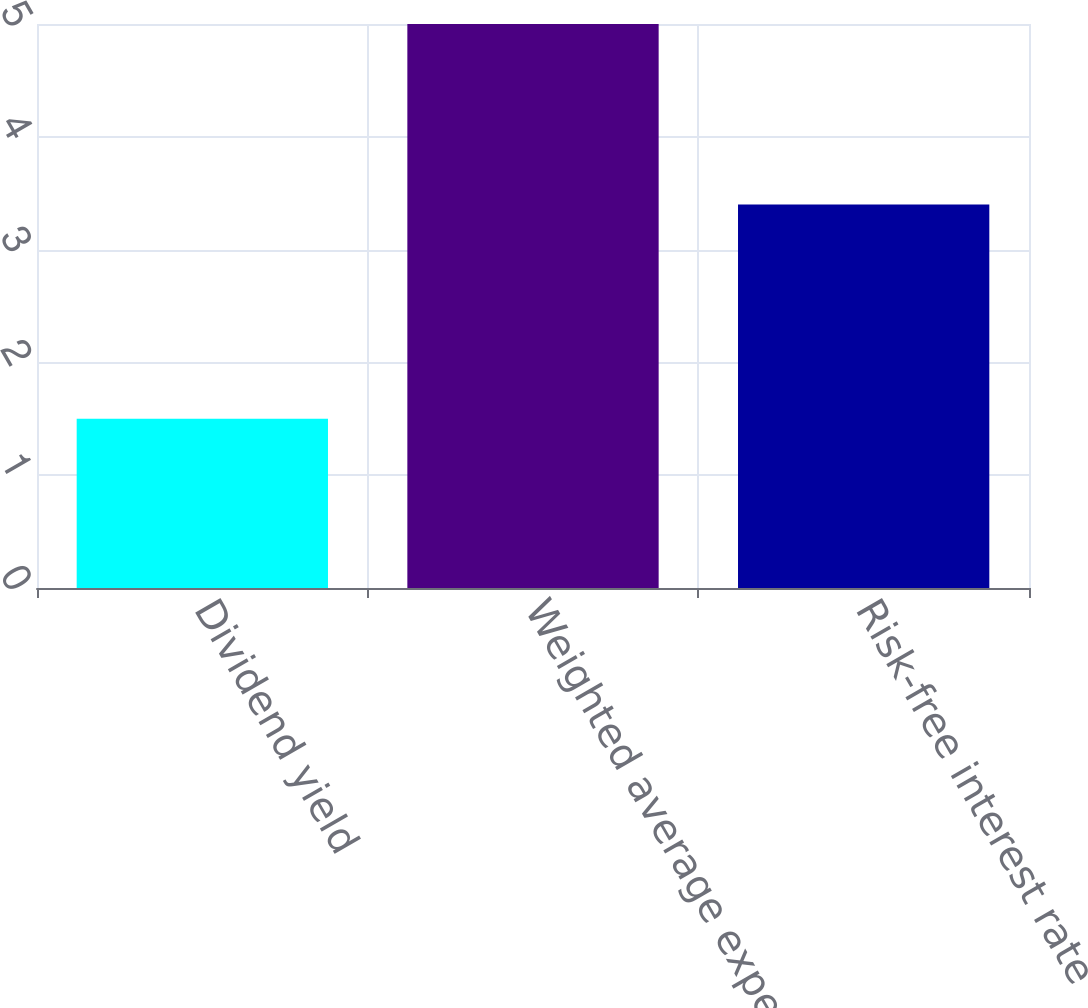<chart> <loc_0><loc_0><loc_500><loc_500><bar_chart><fcel>Dividend yield<fcel>Weighted average expected life<fcel>Risk-free interest rate<nl><fcel>1.5<fcel>5<fcel>3.4<nl></chart> 